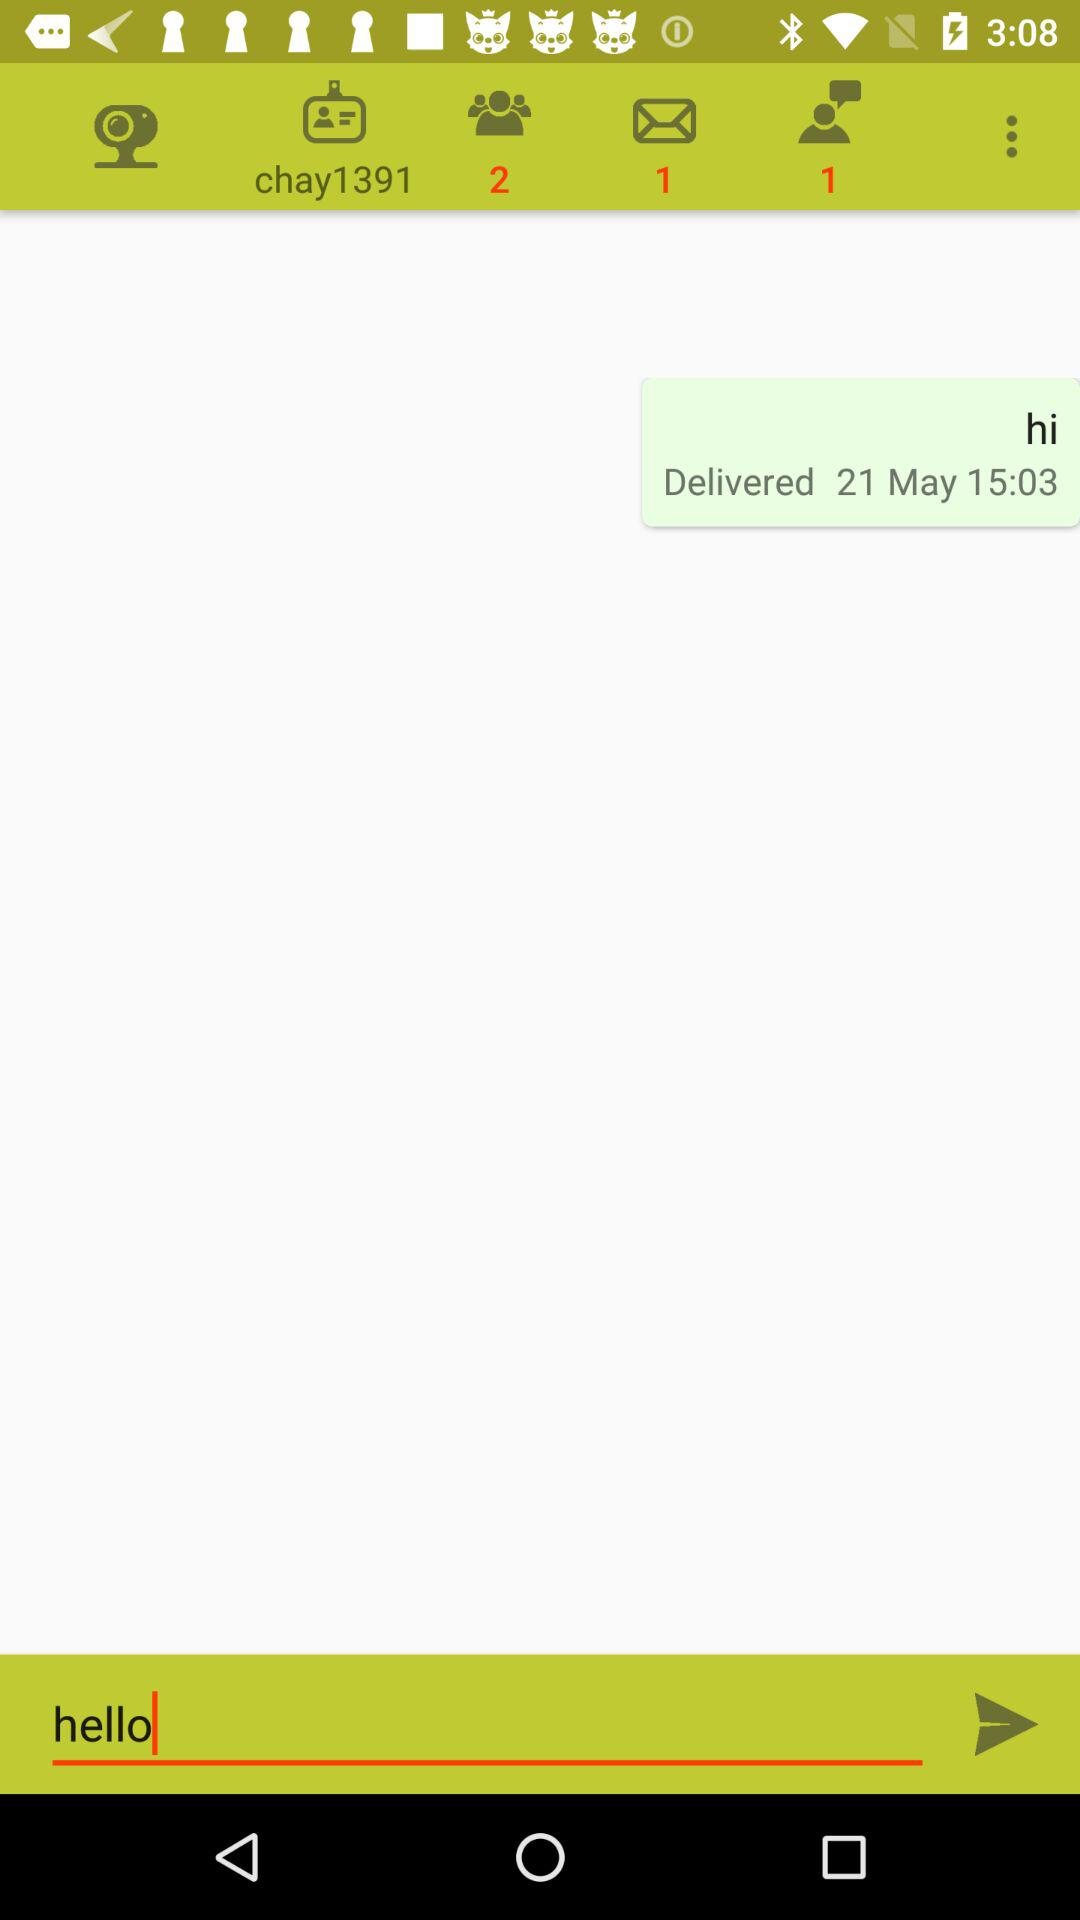Do we have any users online?
When the provided information is insufficient, respond with <no answer>. <no answer> 